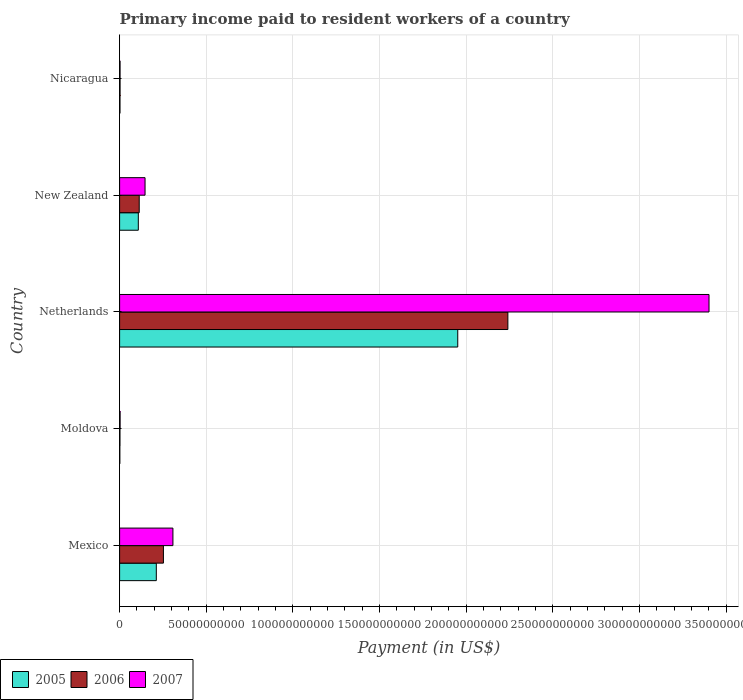How many different coloured bars are there?
Your response must be concise. 3. How many groups of bars are there?
Ensure brevity in your answer.  5. How many bars are there on the 3rd tick from the top?
Make the answer very short. 3. How many bars are there on the 4th tick from the bottom?
Your answer should be compact. 3. What is the label of the 4th group of bars from the top?
Give a very brief answer. Moldova. What is the amount paid to workers in 2007 in Netherlands?
Provide a short and direct response. 3.40e+11. Across all countries, what is the maximum amount paid to workers in 2006?
Offer a terse response. 2.24e+11. Across all countries, what is the minimum amount paid to workers in 2005?
Your answer should be very brief. 1.28e+08. In which country was the amount paid to workers in 2007 minimum?
Offer a terse response. Nicaragua. What is the total amount paid to workers in 2007 in the graph?
Offer a very short reply. 3.86e+11. What is the difference between the amount paid to workers in 2007 in Mexico and that in New Zealand?
Your response must be concise. 1.61e+1. What is the difference between the amount paid to workers in 2007 in New Zealand and the amount paid to workers in 2005 in Nicaragua?
Your response must be concise. 1.45e+1. What is the average amount paid to workers in 2005 per country?
Your response must be concise. 4.55e+1. What is the difference between the amount paid to workers in 2006 and amount paid to workers in 2007 in Nicaragua?
Give a very brief answer. 1.00e+05. What is the ratio of the amount paid to workers in 2006 in New Zealand to that in Nicaragua?
Provide a succinct answer. 43.27. Is the amount paid to workers in 2007 in New Zealand less than that in Nicaragua?
Make the answer very short. No. Is the difference between the amount paid to workers in 2006 in Netherlands and New Zealand greater than the difference between the amount paid to workers in 2007 in Netherlands and New Zealand?
Make the answer very short. No. What is the difference between the highest and the second highest amount paid to workers in 2006?
Offer a terse response. 1.99e+11. What is the difference between the highest and the lowest amount paid to workers in 2005?
Ensure brevity in your answer.  1.95e+11. In how many countries, is the amount paid to workers in 2007 greater than the average amount paid to workers in 2007 taken over all countries?
Ensure brevity in your answer.  1. Is the sum of the amount paid to workers in 2005 in Moldova and Nicaragua greater than the maximum amount paid to workers in 2007 across all countries?
Provide a succinct answer. No. What does the 1st bar from the bottom in New Zealand represents?
Offer a very short reply. 2005. Is it the case that in every country, the sum of the amount paid to workers in 2005 and amount paid to workers in 2006 is greater than the amount paid to workers in 2007?
Offer a terse response. Yes. How many bars are there?
Provide a succinct answer. 15. What is the difference between two consecutive major ticks on the X-axis?
Make the answer very short. 5.00e+1. Are the values on the major ticks of X-axis written in scientific E-notation?
Your answer should be very brief. No. Where does the legend appear in the graph?
Your response must be concise. Bottom left. How many legend labels are there?
Your answer should be compact. 3. How are the legend labels stacked?
Keep it short and to the point. Horizontal. What is the title of the graph?
Your answer should be very brief. Primary income paid to resident workers of a country. What is the label or title of the X-axis?
Your answer should be very brief. Payment (in US$). What is the Payment (in US$) of 2005 in Mexico?
Provide a short and direct response. 2.12e+1. What is the Payment (in US$) of 2006 in Mexico?
Provide a short and direct response. 2.53e+1. What is the Payment (in US$) in 2007 in Mexico?
Provide a succinct answer. 3.08e+1. What is the Payment (in US$) of 2005 in Moldova?
Your response must be concise. 1.28e+08. What is the Payment (in US$) in 2006 in Moldova?
Make the answer very short. 2.03e+08. What is the Payment (in US$) in 2007 in Moldova?
Provide a short and direct response. 2.94e+08. What is the Payment (in US$) in 2005 in Netherlands?
Ensure brevity in your answer.  1.95e+11. What is the Payment (in US$) in 2006 in Netherlands?
Keep it short and to the point. 2.24e+11. What is the Payment (in US$) of 2007 in Netherlands?
Your response must be concise. 3.40e+11. What is the Payment (in US$) of 2005 in New Zealand?
Make the answer very short. 1.08e+1. What is the Payment (in US$) of 2006 in New Zealand?
Your answer should be very brief. 1.13e+1. What is the Payment (in US$) of 2007 in New Zealand?
Offer a very short reply. 1.47e+1. What is the Payment (in US$) of 2005 in Nicaragua?
Your answer should be compact. 2.22e+08. What is the Payment (in US$) of 2006 in Nicaragua?
Give a very brief answer. 2.62e+08. What is the Payment (in US$) in 2007 in Nicaragua?
Your answer should be compact. 2.61e+08. Across all countries, what is the maximum Payment (in US$) of 2005?
Give a very brief answer. 1.95e+11. Across all countries, what is the maximum Payment (in US$) in 2006?
Make the answer very short. 2.24e+11. Across all countries, what is the maximum Payment (in US$) of 2007?
Offer a terse response. 3.40e+11. Across all countries, what is the minimum Payment (in US$) in 2005?
Provide a succinct answer. 1.28e+08. Across all countries, what is the minimum Payment (in US$) in 2006?
Provide a short and direct response. 2.03e+08. Across all countries, what is the minimum Payment (in US$) of 2007?
Your response must be concise. 2.61e+08. What is the total Payment (in US$) of 2005 in the graph?
Provide a succinct answer. 2.27e+11. What is the total Payment (in US$) of 2006 in the graph?
Give a very brief answer. 2.61e+11. What is the total Payment (in US$) of 2007 in the graph?
Keep it short and to the point. 3.86e+11. What is the difference between the Payment (in US$) of 2005 in Mexico and that in Moldova?
Make the answer very short. 2.11e+1. What is the difference between the Payment (in US$) of 2006 in Mexico and that in Moldova?
Provide a succinct answer. 2.51e+1. What is the difference between the Payment (in US$) in 2007 in Mexico and that in Moldova?
Ensure brevity in your answer.  3.05e+1. What is the difference between the Payment (in US$) of 2005 in Mexico and that in Netherlands?
Your response must be concise. -1.74e+11. What is the difference between the Payment (in US$) of 2006 in Mexico and that in Netherlands?
Your response must be concise. -1.99e+11. What is the difference between the Payment (in US$) in 2007 in Mexico and that in Netherlands?
Your answer should be very brief. -3.09e+11. What is the difference between the Payment (in US$) of 2005 in Mexico and that in New Zealand?
Your response must be concise. 1.04e+1. What is the difference between the Payment (in US$) of 2006 in Mexico and that in New Zealand?
Provide a short and direct response. 1.40e+1. What is the difference between the Payment (in US$) in 2007 in Mexico and that in New Zealand?
Ensure brevity in your answer.  1.61e+1. What is the difference between the Payment (in US$) of 2005 in Mexico and that in Nicaragua?
Offer a terse response. 2.10e+1. What is the difference between the Payment (in US$) of 2006 in Mexico and that in Nicaragua?
Your answer should be compact. 2.50e+1. What is the difference between the Payment (in US$) in 2007 in Mexico and that in Nicaragua?
Provide a succinct answer. 3.05e+1. What is the difference between the Payment (in US$) in 2005 in Moldova and that in Netherlands?
Provide a succinct answer. -1.95e+11. What is the difference between the Payment (in US$) in 2006 in Moldova and that in Netherlands?
Offer a very short reply. -2.24e+11. What is the difference between the Payment (in US$) of 2007 in Moldova and that in Netherlands?
Provide a succinct answer. -3.40e+11. What is the difference between the Payment (in US$) of 2005 in Moldova and that in New Zealand?
Your response must be concise. -1.07e+1. What is the difference between the Payment (in US$) in 2006 in Moldova and that in New Zealand?
Provide a succinct answer. -1.11e+1. What is the difference between the Payment (in US$) of 2007 in Moldova and that in New Zealand?
Provide a short and direct response. -1.44e+1. What is the difference between the Payment (in US$) of 2005 in Moldova and that in Nicaragua?
Your answer should be compact. -9.36e+07. What is the difference between the Payment (in US$) of 2006 in Moldova and that in Nicaragua?
Offer a very short reply. -5.81e+07. What is the difference between the Payment (in US$) in 2007 in Moldova and that in Nicaragua?
Keep it short and to the point. 3.23e+07. What is the difference between the Payment (in US$) in 2005 in Netherlands and that in New Zealand?
Offer a very short reply. 1.84e+11. What is the difference between the Payment (in US$) in 2006 in Netherlands and that in New Zealand?
Keep it short and to the point. 2.13e+11. What is the difference between the Payment (in US$) in 2007 in Netherlands and that in New Zealand?
Give a very brief answer. 3.25e+11. What is the difference between the Payment (in US$) in 2005 in Netherlands and that in Nicaragua?
Give a very brief answer. 1.95e+11. What is the difference between the Payment (in US$) of 2006 in Netherlands and that in Nicaragua?
Provide a short and direct response. 2.24e+11. What is the difference between the Payment (in US$) in 2007 in Netherlands and that in Nicaragua?
Provide a succinct answer. 3.40e+11. What is the difference between the Payment (in US$) of 2005 in New Zealand and that in Nicaragua?
Your response must be concise. 1.06e+1. What is the difference between the Payment (in US$) of 2006 in New Zealand and that in Nicaragua?
Provide a short and direct response. 1.11e+1. What is the difference between the Payment (in US$) of 2007 in New Zealand and that in Nicaragua?
Give a very brief answer. 1.44e+1. What is the difference between the Payment (in US$) in 2005 in Mexico and the Payment (in US$) in 2006 in Moldova?
Your answer should be compact. 2.10e+1. What is the difference between the Payment (in US$) in 2005 in Mexico and the Payment (in US$) in 2007 in Moldova?
Your response must be concise. 2.09e+1. What is the difference between the Payment (in US$) of 2006 in Mexico and the Payment (in US$) of 2007 in Moldova?
Your answer should be very brief. 2.50e+1. What is the difference between the Payment (in US$) in 2005 in Mexico and the Payment (in US$) in 2006 in Netherlands?
Make the answer very short. -2.03e+11. What is the difference between the Payment (in US$) of 2005 in Mexico and the Payment (in US$) of 2007 in Netherlands?
Make the answer very short. -3.19e+11. What is the difference between the Payment (in US$) of 2006 in Mexico and the Payment (in US$) of 2007 in Netherlands?
Ensure brevity in your answer.  -3.15e+11. What is the difference between the Payment (in US$) of 2005 in Mexico and the Payment (in US$) of 2006 in New Zealand?
Offer a terse response. 9.87e+09. What is the difference between the Payment (in US$) in 2005 in Mexico and the Payment (in US$) in 2007 in New Zealand?
Make the answer very short. 6.50e+09. What is the difference between the Payment (in US$) in 2006 in Mexico and the Payment (in US$) in 2007 in New Zealand?
Ensure brevity in your answer.  1.06e+1. What is the difference between the Payment (in US$) in 2005 in Mexico and the Payment (in US$) in 2006 in Nicaragua?
Your response must be concise. 2.09e+1. What is the difference between the Payment (in US$) of 2005 in Mexico and the Payment (in US$) of 2007 in Nicaragua?
Your answer should be very brief. 2.09e+1. What is the difference between the Payment (in US$) of 2006 in Mexico and the Payment (in US$) of 2007 in Nicaragua?
Provide a short and direct response. 2.50e+1. What is the difference between the Payment (in US$) in 2005 in Moldova and the Payment (in US$) in 2006 in Netherlands?
Make the answer very short. -2.24e+11. What is the difference between the Payment (in US$) in 2005 in Moldova and the Payment (in US$) in 2007 in Netherlands?
Offer a terse response. -3.40e+11. What is the difference between the Payment (in US$) of 2006 in Moldova and the Payment (in US$) of 2007 in Netherlands?
Your answer should be very brief. -3.40e+11. What is the difference between the Payment (in US$) of 2005 in Moldova and the Payment (in US$) of 2006 in New Zealand?
Your response must be concise. -1.12e+1. What is the difference between the Payment (in US$) in 2005 in Moldova and the Payment (in US$) in 2007 in New Zealand?
Offer a very short reply. -1.46e+1. What is the difference between the Payment (in US$) of 2006 in Moldova and the Payment (in US$) of 2007 in New Zealand?
Provide a short and direct response. -1.45e+1. What is the difference between the Payment (in US$) in 2005 in Moldova and the Payment (in US$) in 2006 in Nicaragua?
Make the answer very short. -1.33e+08. What is the difference between the Payment (in US$) in 2005 in Moldova and the Payment (in US$) in 2007 in Nicaragua?
Keep it short and to the point. -1.33e+08. What is the difference between the Payment (in US$) in 2006 in Moldova and the Payment (in US$) in 2007 in Nicaragua?
Provide a succinct answer. -5.80e+07. What is the difference between the Payment (in US$) in 2005 in Netherlands and the Payment (in US$) in 2006 in New Zealand?
Offer a very short reply. 1.84e+11. What is the difference between the Payment (in US$) of 2005 in Netherlands and the Payment (in US$) of 2007 in New Zealand?
Ensure brevity in your answer.  1.80e+11. What is the difference between the Payment (in US$) of 2006 in Netherlands and the Payment (in US$) of 2007 in New Zealand?
Provide a short and direct response. 2.09e+11. What is the difference between the Payment (in US$) of 2005 in Netherlands and the Payment (in US$) of 2006 in Nicaragua?
Offer a terse response. 1.95e+11. What is the difference between the Payment (in US$) in 2005 in Netherlands and the Payment (in US$) in 2007 in Nicaragua?
Provide a short and direct response. 1.95e+11. What is the difference between the Payment (in US$) of 2006 in Netherlands and the Payment (in US$) of 2007 in Nicaragua?
Make the answer very short. 2.24e+11. What is the difference between the Payment (in US$) in 2005 in New Zealand and the Payment (in US$) in 2006 in Nicaragua?
Provide a succinct answer. 1.05e+1. What is the difference between the Payment (in US$) in 2005 in New Zealand and the Payment (in US$) in 2007 in Nicaragua?
Provide a short and direct response. 1.05e+1. What is the difference between the Payment (in US$) in 2006 in New Zealand and the Payment (in US$) in 2007 in Nicaragua?
Provide a succinct answer. 1.11e+1. What is the average Payment (in US$) in 2005 per country?
Keep it short and to the point. 4.55e+1. What is the average Payment (in US$) of 2006 per country?
Give a very brief answer. 5.22e+1. What is the average Payment (in US$) in 2007 per country?
Ensure brevity in your answer.  7.72e+1. What is the difference between the Payment (in US$) of 2005 and Payment (in US$) of 2006 in Mexico?
Provide a succinct answer. -4.10e+09. What is the difference between the Payment (in US$) of 2005 and Payment (in US$) of 2007 in Mexico?
Offer a very short reply. -9.58e+09. What is the difference between the Payment (in US$) in 2006 and Payment (in US$) in 2007 in Mexico?
Ensure brevity in your answer.  -5.48e+09. What is the difference between the Payment (in US$) in 2005 and Payment (in US$) in 2006 in Moldova?
Provide a short and direct response. -7.50e+07. What is the difference between the Payment (in US$) in 2005 and Payment (in US$) in 2007 in Moldova?
Make the answer very short. -1.65e+08. What is the difference between the Payment (in US$) of 2006 and Payment (in US$) of 2007 in Moldova?
Your response must be concise. -9.03e+07. What is the difference between the Payment (in US$) of 2005 and Payment (in US$) of 2006 in Netherlands?
Make the answer very short. -2.89e+1. What is the difference between the Payment (in US$) of 2005 and Payment (in US$) of 2007 in Netherlands?
Offer a very short reply. -1.45e+11. What is the difference between the Payment (in US$) of 2006 and Payment (in US$) of 2007 in Netherlands?
Keep it short and to the point. -1.16e+11. What is the difference between the Payment (in US$) of 2005 and Payment (in US$) of 2006 in New Zealand?
Provide a succinct answer. -5.20e+08. What is the difference between the Payment (in US$) in 2005 and Payment (in US$) in 2007 in New Zealand?
Offer a terse response. -3.88e+09. What is the difference between the Payment (in US$) of 2006 and Payment (in US$) of 2007 in New Zealand?
Provide a succinct answer. -3.36e+09. What is the difference between the Payment (in US$) of 2005 and Payment (in US$) of 2006 in Nicaragua?
Offer a very short reply. -3.95e+07. What is the difference between the Payment (in US$) in 2005 and Payment (in US$) in 2007 in Nicaragua?
Keep it short and to the point. -3.94e+07. What is the ratio of the Payment (in US$) of 2005 in Mexico to that in Moldova?
Provide a short and direct response. 164.99. What is the ratio of the Payment (in US$) in 2006 in Mexico to that in Moldova?
Your answer should be very brief. 124.33. What is the ratio of the Payment (in US$) in 2007 in Mexico to that in Moldova?
Keep it short and to the point. 104.75. What is the ratio of the Payment (in US$) in 2005 in Mexico to that in Netherlands?
Ensure brevity in your answer.  0.11. What is the ratio of the Payment (in US$) in 2006 in Mexico to that in Netherlands?
Give a very brief answer. 0.11. What is the ratio of the Payment (in US$) in 2007 in Mexico to that in Netherlands?
Provide a short and direct response. 0.09. What is the ratio of the Payment (in US$) in 2005 in Mexico to that in New Zealand?
Ensure brevity in your answer.  1.96. What is the ratio of the Payment (in US$) of 2006 in Mexico to that in New Zealand?
Ensure brevity in your answer.  2.23. What is the ratio of the Payment (in US$) in 2007 in Mexico to that in New Zealand?
Offer a terse response. 2.1. What is the ratio of the Payment (in US$) of 2005 in Mexico to that in Nicaragua?
Offer a terse response. 95.41. What is the ratio of the Payment (in US$) in 2006 in Mexico to that in Nicaragua?
Your answer should be very brief. 96.69. What is the ratio of the Payment (in US$) of 2007 in Mexico to that in Nicaragua?
Offer a terse response. 117.68. What is the ratio of the Payment (in US$) in 2005 in Moldova to that in Netherlands?
Your response must be concise. 0. What is the ratio of the Payment (in US$) of 2006 in Moldova to that in Netherlands?
Keep it short and to the point. 0. What is the ratio of the Payment (in US$) in 2007 in Moldova to that in Netherlands?
Your answer should be very brief. 0. What is the ratio of the Payment (in US$) of 2005 in Moldova to that in New Zealand?
Your answer should be very brief. 0.01. What is the ratio of the Payment (in US$) in 2006 in Moldova to that in New Zealand?
Keep it short and to the point. 0.02. What is the ratio of the Payment (in US$) of 2005 in Moldova to that in Nicaragua?
Offer a very short reply. 0.58. What is the ratio of the Payment (in US$) in 2006 in Moldova to that in Nicaragua?
Offer a very short reply. 0.78. What is the ratio of the Payment (in US$) in 2007 in Moldova to that in Nicaragua?
Your response must be concise. 1.12. What is the ratio of the Payment (in US$) of 2005 in Netherlands to that in New Zealand?
Offer a terse response. 18.07. What is the ratio of the Payment (in US$) in 2006 in Netherlands to that in New Zealand?
Your answer should be compact. 19.8. What is the ratio of the Payment (in US$) in 2007 in Netherlands to that in New Zealand?
Your response must be concise. 23.17. What is the ratio of the Payment (in US$) of 2005 in Netherlands to that in Nicaragua?
Offer a terse response. 878.79. What is the ratio of the Payment (in US$) of 2006 in Netherlands to that in Nicaragua?
Provide a short and direct response. 856.65. What is the ratio of the Payment (in US$) in 2007 in Netherlands to that in Nicaragua?
Provide a short and direct response. 1300.93. What is the ratio of the Payment (in US$) in 2005 in New Zealand to that in Nicaragua?
Provide a succinct answer. 48.63. What is the ratio of the Payment (in US$) of 2006 in New Zealand to that in Nicaragua?
Make the answer very short. 43.27. What is the ratio of the Payment (in US$) in 2007 in New Zealand to that in Nicaragua?
Ensure brevity in your answer.  56.16. What is the difference between the highest and the second highest Payment (in US$) of 2005?
Offer a very short reply. 1.74e+11. What is the difference between the highest and the second highest Payment (in US$) in 2006?
Your answer should be very brief. 1.99e+11. What is the difference between the highest and the second highest Payment (in US$) in 2007?
Offer a terse response. 3.09e+11. What is the difference between the highest and the lowest Payment (in US$) of 2005?
Make the answer very short. 1.95e+11. What is the difference between the highest and the lowest Payment (in US$) in 2006?
Ensure brevity in your answer.  2.24e+11. What is the difference between the highest and the lowest Payment (in US$) of 2007?
Provide a short and direct response. 3.40e+11. 